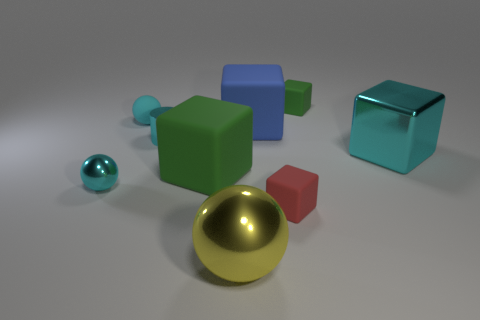What number of other objects are the same material as the small green cube?
Your answer should be compact. 4. Does the yellow sphere have the same size as the cyan shiny cube?
Give a very brief answer. Yes. There is a small matte thing that is in front of the small matte ball; what shape is it?
Make the answer very short. Cube. The metallic sphere left of the object that is in front of the red rubber cube is what color?
Ensure brevity in your answer.  Cyan. There is a green object that is on the right side of the big blue object; does it have the same shape as the shiny thing that is in front of the red rubber block?
Give a very brief answer. No. There is a red thing that is the same size as the shiny cylinder; what shape is it?
Ensure brevity in your answer.  Cube. The block that is made of the same material as the cyan cylinder is what color?
Provide a succinct answer. Cyan. There is a blue rubber thing; is its shape the same as the yellow object that is in front of the blue rubber thing?
Make the answer very short. No. What material is the big thing that is the same color as the tiny cylinder?
Offer a very short reply. Metal. There is a cyan thing that is the same size as the yellow ball; what is it made of?
Provide a short and direct response. Metal. 